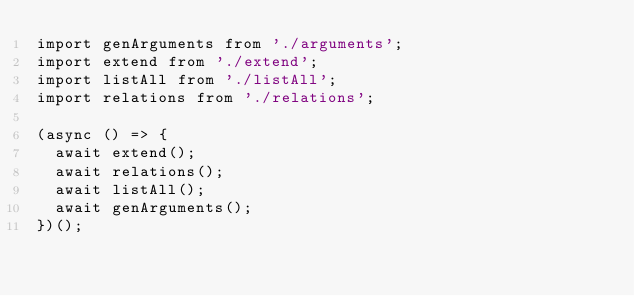Convert code to text. <code><loc_0><loc_0><loc_500><loc_500><_TypeScript_>import genArguments from './arguments';
import extend from './extend';
import listAll from './listAll';
import relations from './relations';

(async () => {
  await extend();
  await relations();
  await listAll();
  await genArguments();
})();
</code> 